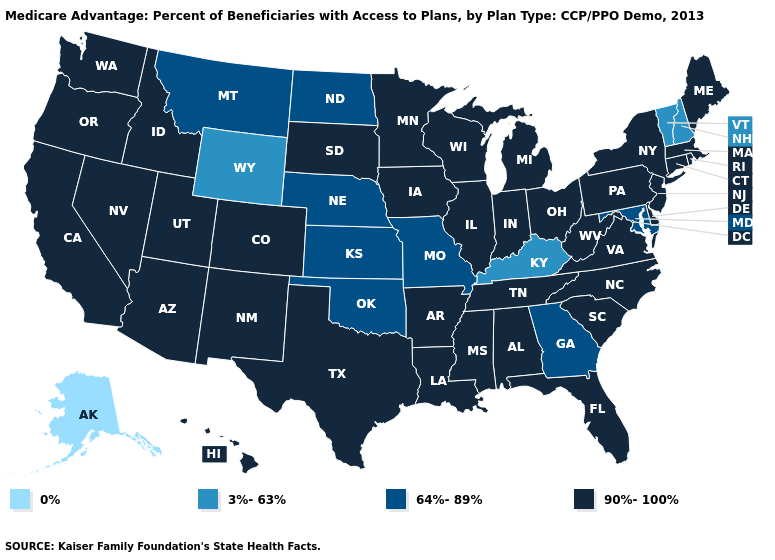Name the states that have a value in the range 0%?
Concise answer only. Alaska. What is the value of Massachusetts?
Short answer required. 90%-100%. Name the states that have a value in the range 0%?
Give a very brief answer. Alaska. What is the lowest value in the South?
Concise answer only. 3%-63%. Among the states that border Michigan , which have the lowest value?
Be succinct. Indiana, Ohio, Wisconsin. Name the states that have a value in the range 90%-100%?
Short answer required. Alabama, Arkansas, Arizona, California, Colorado, Connecticut, Delaware, Florida, Hawaii, Iowa, Idaho, Illinois, Indiana, Louisiana, Massachusetts, Maine, Michigan, Minnesota, Mississippi, North Carolina, New Jersey, New Mexico, Nevada, New York, Ohio, Oregon, Pennsylvania, Rhode Island, South Carolina, South Dakota, Tennessee, Texas, Utah, Virginia, Washington, Wisconsin, West Virginia. What is the value of South Carolina?
Short answer required. 90%-100%. Does the first symbol in the legend represent the smallest category?
Be succinct. Yes. Name the states that have a value in the range 64%-89%?
Keep it brief. Georgia, Kansas, Maryland, Missouri, Montana, North Dakota, Nebraska, Oklahoma. Does Rhode Island have the lowest value in the USA?
Be succinct. No. How many symbols are there in the legend?
Keep it brief. 4. Is the legend a continuous bar?
Write a very short answer. No. What is the lowest value in the USA?
Be succinct. 0%. Name the states that have a value in the range 90%-100%?
Be succinct. Alabama, Arkansas, Arizona, California, Colorado, Connecticut, Delaware, Florida, Hawaii, Iowa, Idaho, Illinois, Indiana, Louisiana, Massachusetts, Maine, Michigan, Minnesota, Mississippi, North Carolina, New Jersey, New Mexico, Nevada, New York, Ohio, Oregon, Pennsylvania, Rhode Island, South Carolina, South Dakota, Tennessee, Texas, Utah, Virginia, Washington, Wisconsin, West Virginia. What is the value of Wisconsin?
Concise answer only. 90%-100%. 